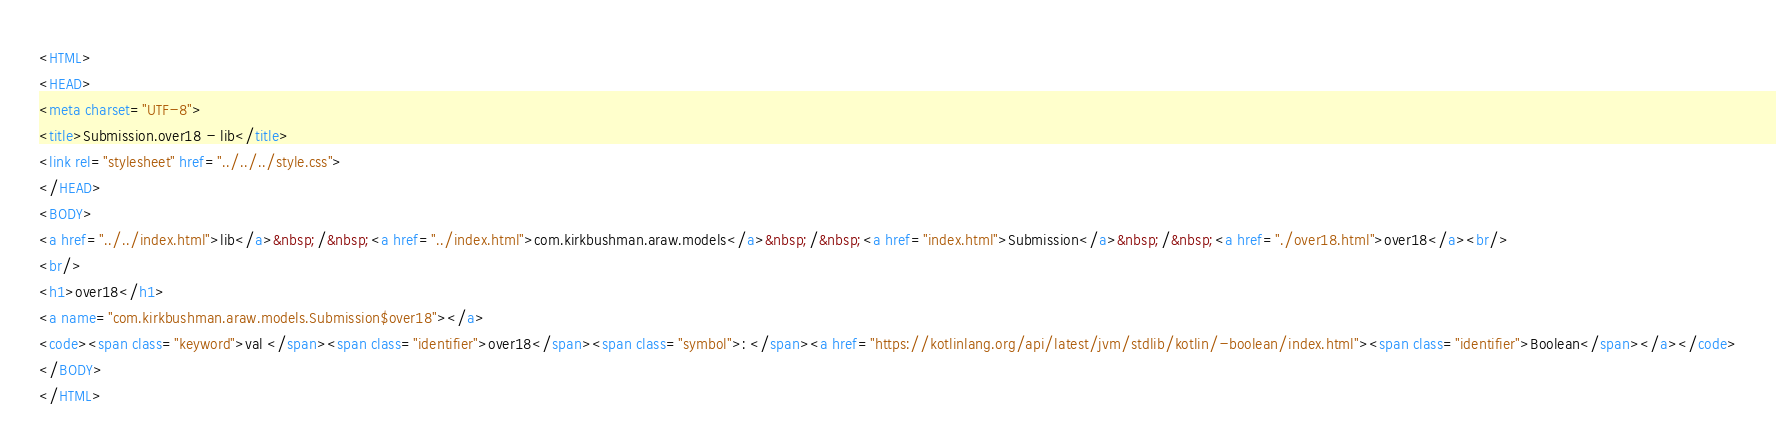Convert code to text. <code><loc_0><loc_0><loc_500><loc_500><_HTML_><HTML>
<HEAD>
<meta charset="UTF-8">
<title>Submission.over18 - lib</title>
<link rel="stylesheet" href="../../../style.css">
</HEAD>
<BODY>
<a href="../../index.html">lib</a>&nbsp;/&nbsp;<a href="../index.html">com.kirkbushman.araw.models</a>&nbsp;/&nbsp;<a href="index.html">Submission</a>&nbsp;/&nbsp;<a href="./over18.html">over18</a><br/>
<br/>
<h1>over18</h1>
<a name="com.kirkbushman.araw.models.Submission$over18"></a>
<code><span class="keyword">val </span><span class="identifier">over18</span><span class="symbol">: </span><a href="https://kotlinlang.org/api/latest/jvm/stdlib/kotlin/-boolean/index.html"><span class="identifier">Boolean</span></a></code>
</BODY>
</HTML>
</code> 